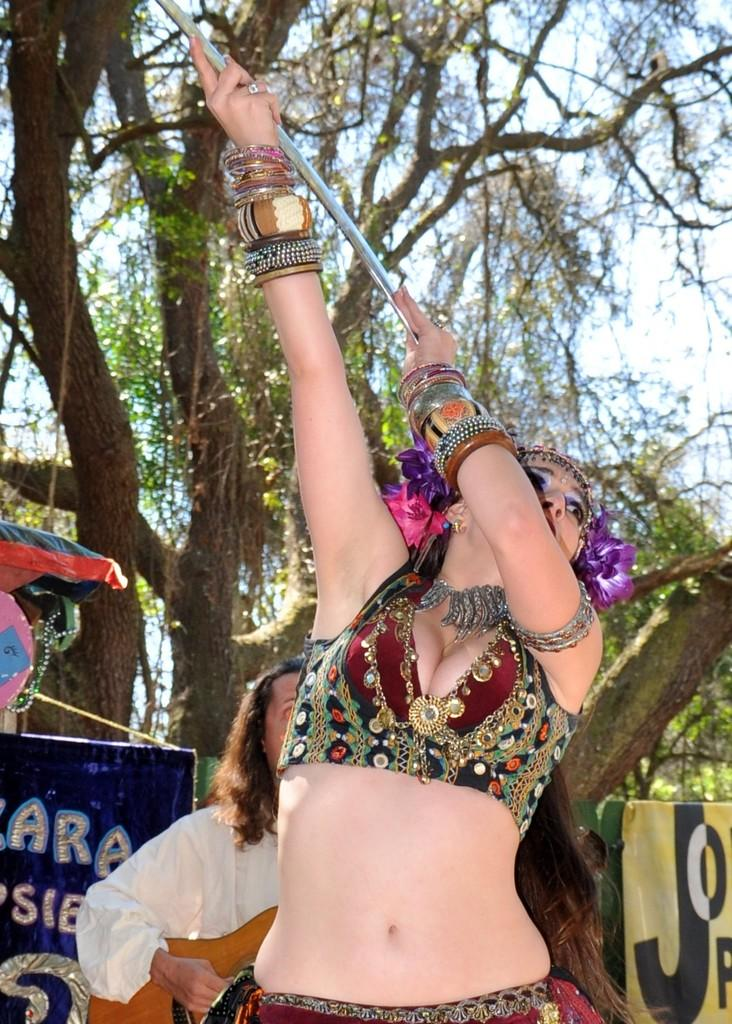Who is the main subject in the foreground of the image? There is a woman in the foreground of the image. What is the woman holding in the image? The woman is holding a rod in the image. What might the woman be doing in the image? The woman appears to be dancing in the image. What can be seen in the background of the image? There is a man with a guitar, banners, trees, and the sky visible in the background of the image. What type of pie is being served to the frogs in the image? There are no frogs or pies present in the image. Is the queen present in the image? There is no mention of a queen in the image. 